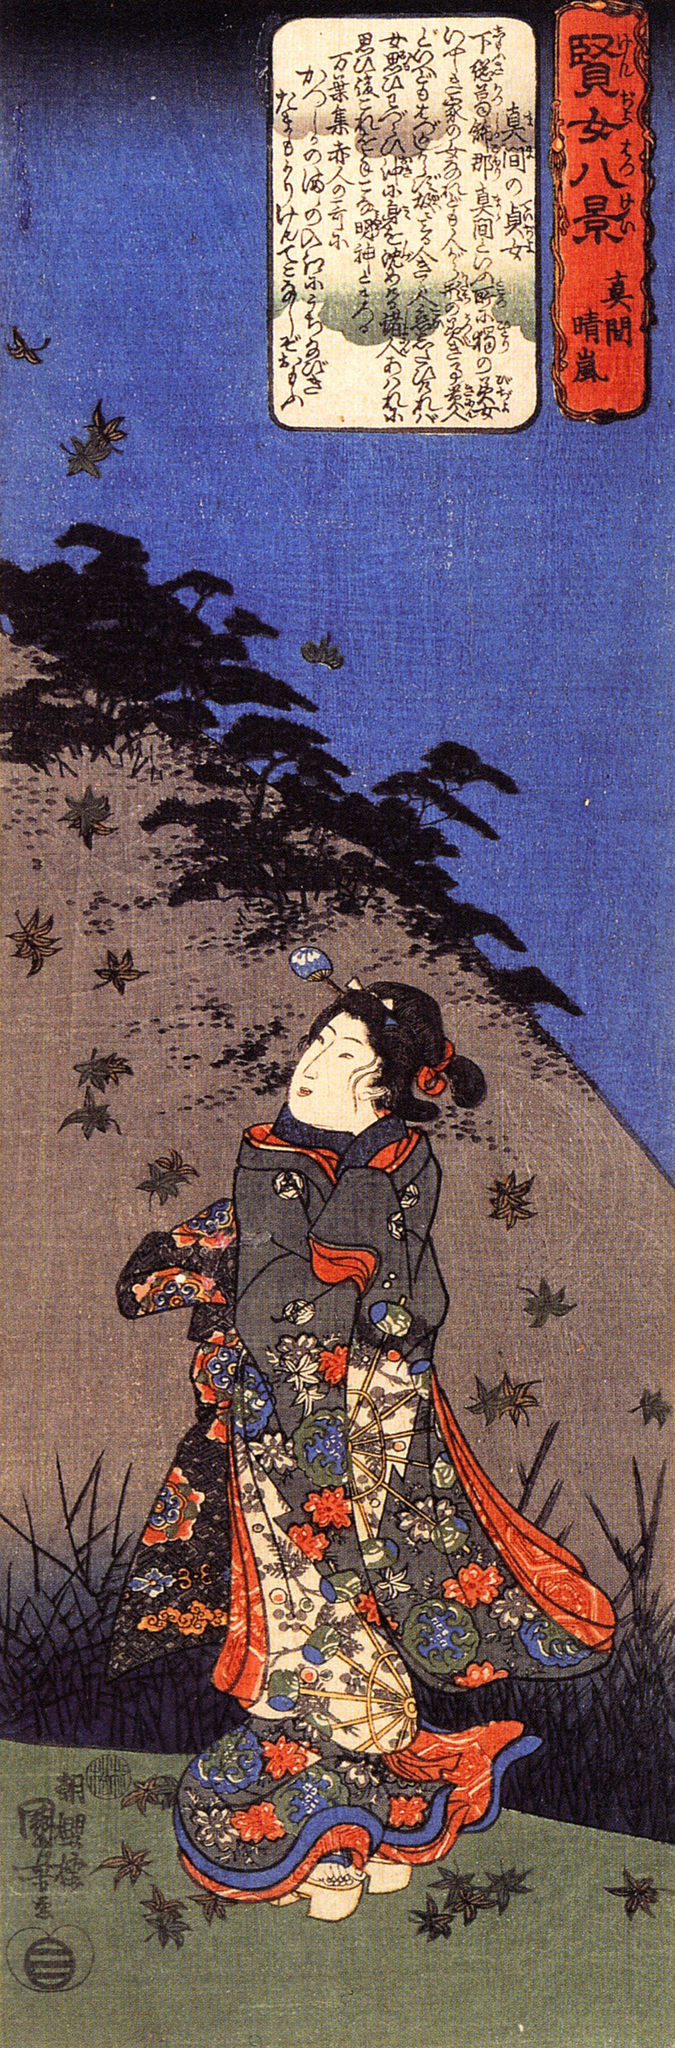Write a detailed description of the given image. This artwork is a striking example of the ukiyo-e art style, a prominent genre in Japan from the 17th to 19th centuries. The piece has a vertical composition that guides the viewer's eye from the foreground up to the top of the frame, each element contributing to its intricate narrative.

In the foreground stands a woman dressed in an elaborate and vibrant kimono. Her attire is a vivid mix of blue, red, green, and yellow, showcasing intricate floral patterns and motifs. She is gazing upwards, her expression indicating a sense of wonder or contemplation, perhaps captivated by the scene unfolding around her.

The background features a deep, rich blue sky that contrasts sharply with the colorful kimono of the woman. A flock of birds flies over a lush mountain, adding a dynamic sense of movement and depth to the image. This scene evokes the serene beauty of nature and its harmonious interaction with humanity.

In the top right corner, a white text box with black Japanese calligraphy provides context to the scene, with the text '山の上に', translating to 'on top of the mountain'. This brief phrase invites viewers to ponder the significance of the mountain and its place in the composition.

Overall, this image masterfully blends vibrant colors, intricate details, and a compelling narrative, highlighting the timeless elegance and cultural richness of Japanese woodblock prints from the Edo period. 